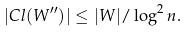<formula> <loc_0><loc_0><loc_500><loc_500>| C l ( W ^ { \prime \prime } ) | \leq | W | / \log ^ { 2 } n .</formula> 